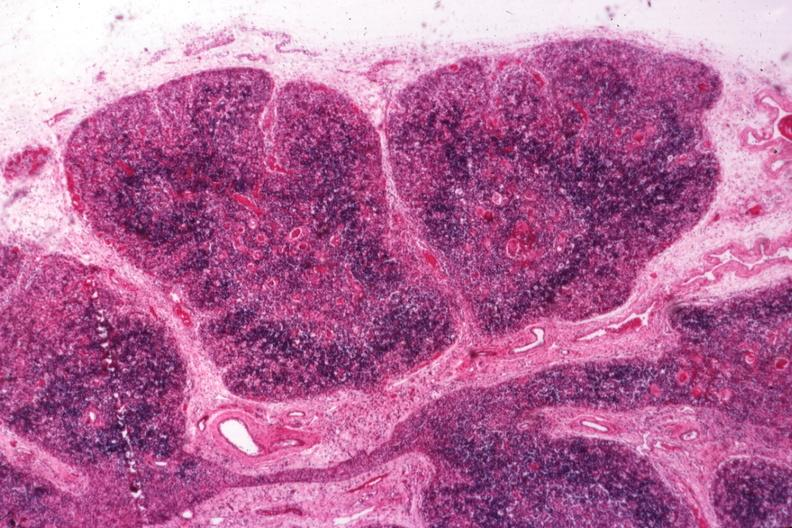s lymphoid atrophy in newborn present?
Answer the question using a single word or phrase. Yes 